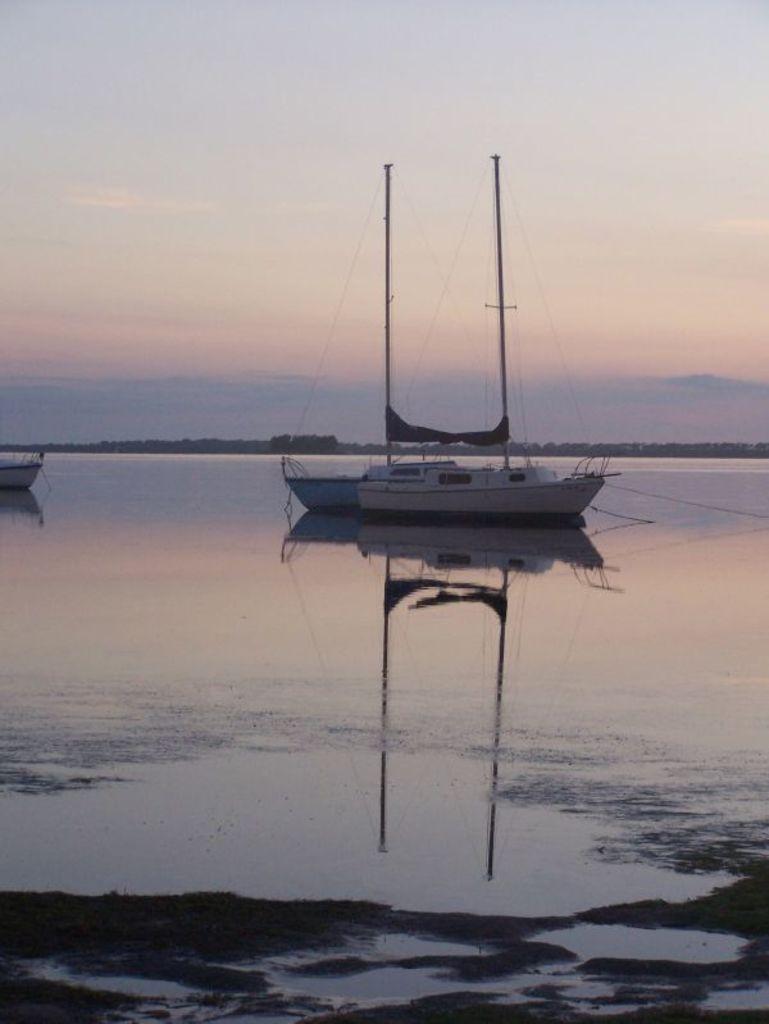Could you give a brief overview of what you see in this image? In this image we can see boats on the water. In the background there is sky with clouds. 